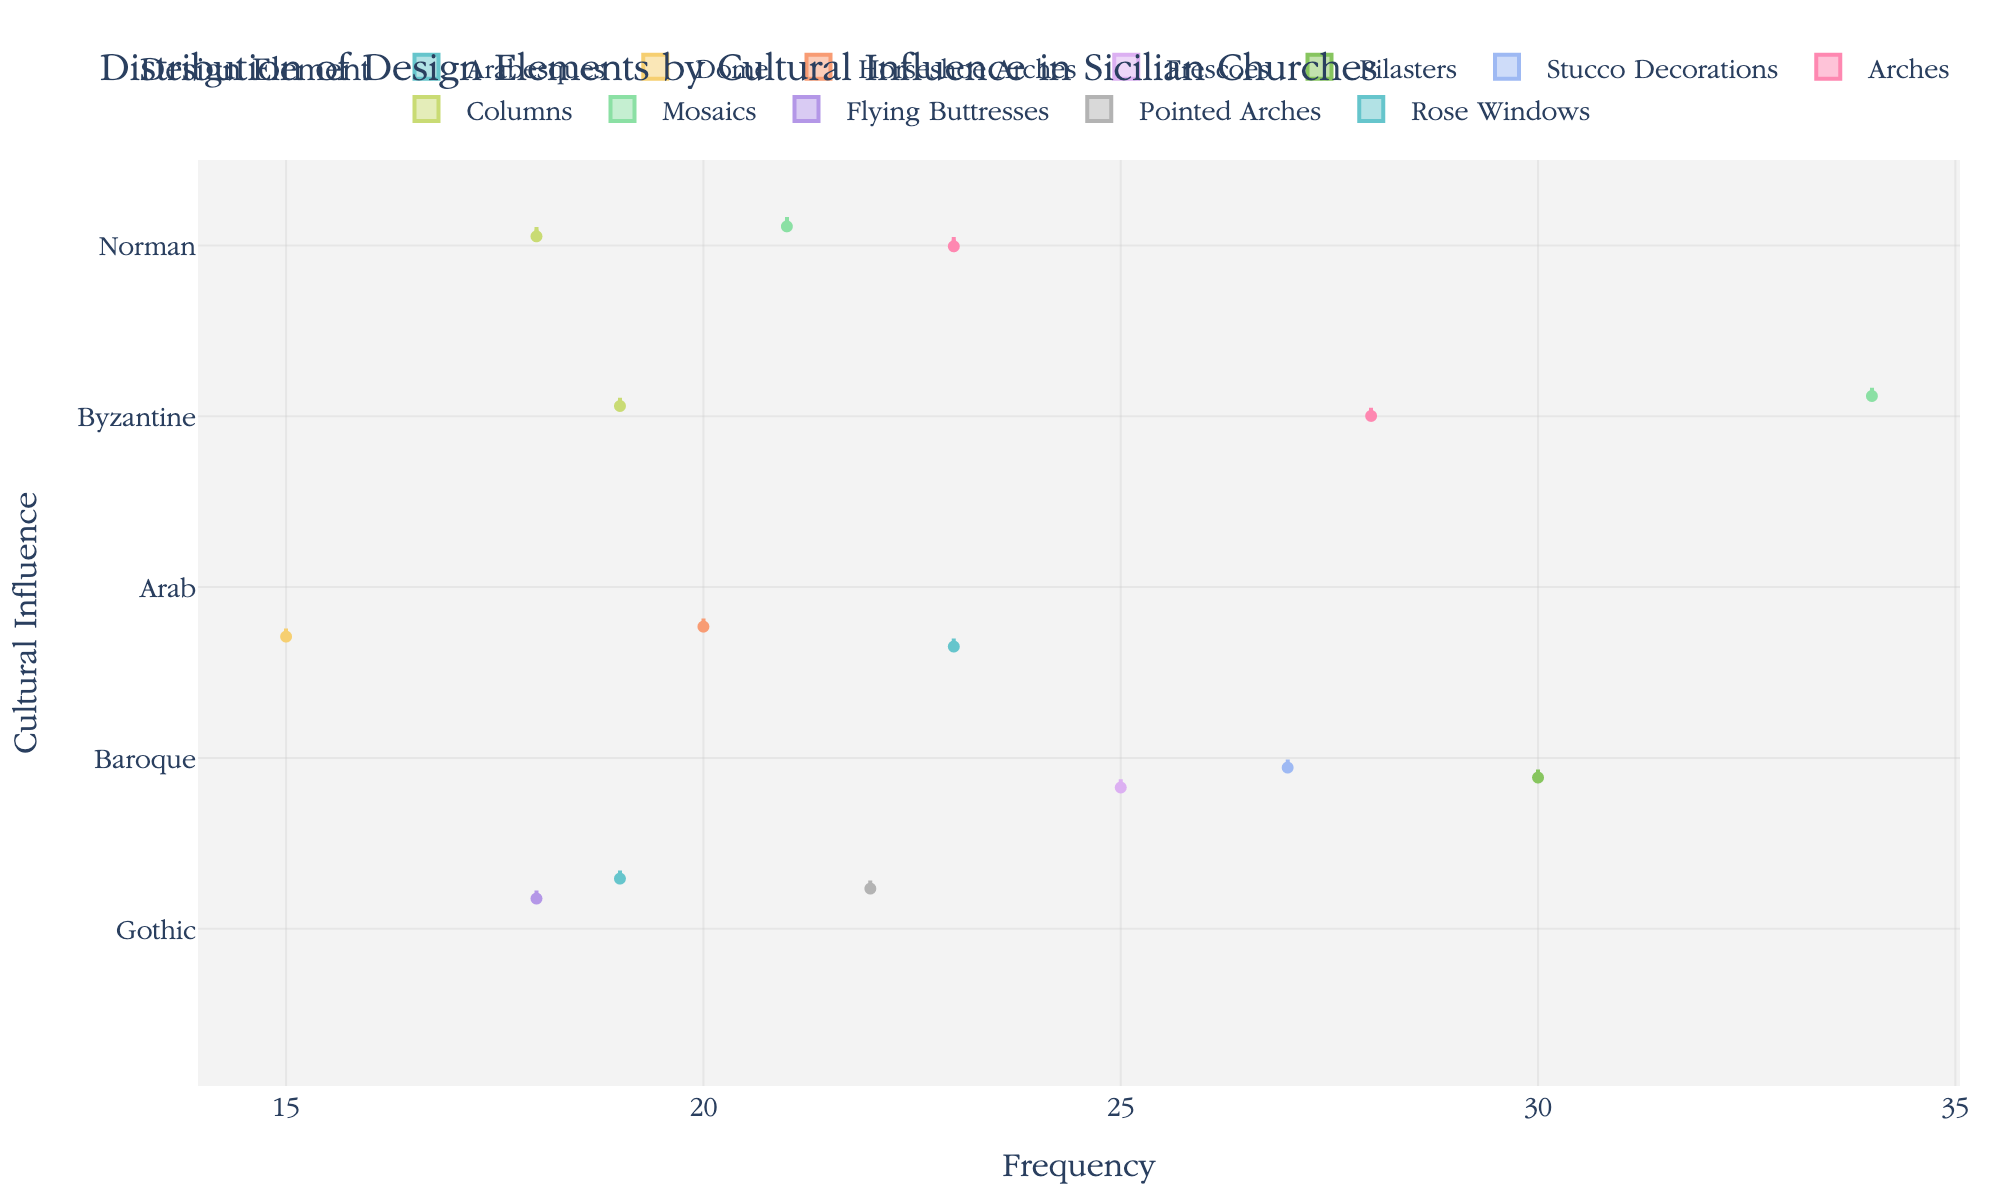what is the most frequent design element in Byzantine influenced churches? Looking at the horizontal violin plots for Byzantine, the tallest one represents Mosaics, indicating that Mosaics is the most frequent design element in Byzantine influenced churches
Answer: Mosaics what is the total count of design elements from Arab and Gothic influences combined? Summing the Counts for Arab and Gothic design elements from the figure, you get Arab: Dome (15) + Arabesques (23) + Horseshoe Arches (20) = 58, and Gothic: Flying Buttresses (18) + Pointed Arches (22) + Rose Windows (19) = 59. Adding them together gives 58 + 59 = 117
Answer: 117 which cultural influence has the least variation in design element frequency? On the horizontal violin chart, the width of the violins reflects the variation in frequency. The Cultural Influence with the narrowest violins would have the least variation. In this case, Baroque shows the least width variation, indicating the least variation in design element frequency
Answer: Baroque how many different design elements are represented in Baroque influenced churches? By identifying the different segments within the Baroque category on the y-axis, you can count the distinctly colored segments, which are Pilasters, Stucco Decorations, and Frescoes. Thus, there are three different design elements
Answer: 3 which cultural influence has a higher frequency of arches, Norman or Byzantine? Comparing the height of the violin plots for the "Arches" design element under both Norman and Byzantine influences, Byzantine has a higher frequency with a count of 28 compared to Norman's 23
Answer: Byzantine what is the median frequency of design elements in Gothic influenced churches? The violin plots with the embedded box plots show the median line. For Gothic, the medians for Flying Buttresses, Pointed Arches, and Rose Windows are approximately: 18, 22, and 19 respectively. Thus, to find the overall median, you can order these values which gives the middle value as 19
Answer: 19 which design element has a count of 30 in any cultural influence? Looking at the chart, the specific count of 30 can be observed in the violin for Pilasters under the Baroque Cultural Influence
Answer: Pilasters which cultural influence has the smallest total count for its design elements? Adding up the counts within each cultural influence, we determine the smallest total:
- Norman: Arches (23) + Columns (18) + Mosaics (21) = 62
- Byzantine: Arches (28) + Mosaics (34) + Columns (19) = 81
- Arab: Dome (15) + Arabesques (23) + Horseshoe Arches (20) = 58
- Baroque: Pilasters (30) + Stucco Decorations (27) + Frescoes (25) = 82
- Gothic: Flying Buttresses (18) + Pointed Arches (22) + Rose Windows (19) = 59. Therefore, Arab has the smallest total count at 58
Answer: Arab 